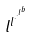Convert formula to latex. <formula><loc_0><loc_0><loc_500><loc_500>l ^ { l ^ { \cdot ^ { \cdot ^ { l ^ { b } } } } }</formula> 